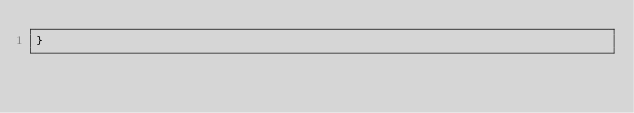<code> <loc_0><loc_0><loc_500><loc_500><_Scala_>}
</code> 